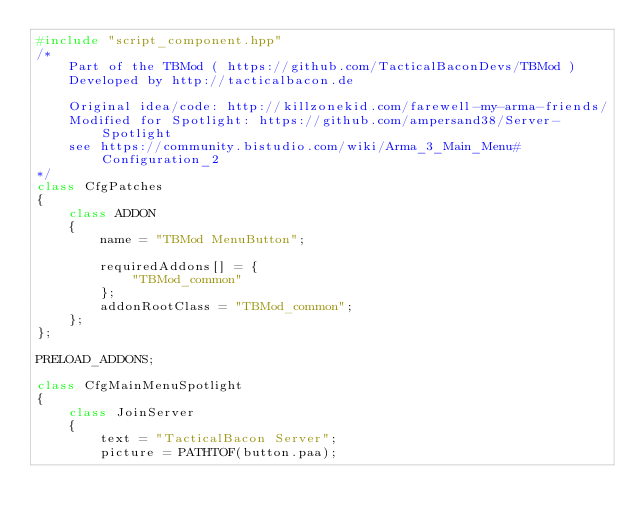Convert code to text. <code><loc_0><loc_0><loc_500><loc_500><_C++_>#include "script_component.hpp"
/*
    Part of the TBMod ( https://github.com/TacticalBaconDevs/TBMod )
    Developed by http://tacticalbacon.de

    Original idea/code: http://killzonekid.com/farewell-my-arma-friends/
    Modified for Spotlight: https://github.com/ampersand38/Server-Spotlight
    see https://community.bistudio.com/wiki/Arma_3_Main_Menu#Configuration_2
*/
class CfgPatches
{
    class ADDON
    {
        name = "TBMod MenuButton";

        requiredAddons[] = {
            "TBMod_common"
        };
        addonRootClass = "TBMod_common";
    };
};

PRELOAD_ADDONS;

class CfgMainMenuSpotlight
{
    class JoinServer
    {
        text = "TacticalBacon Server";
        picture = PATHTOF(button.paa);</code> 